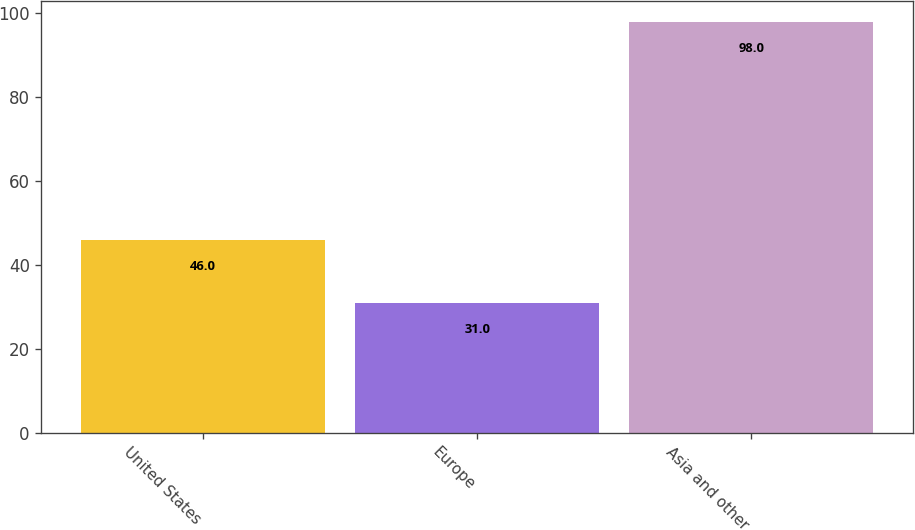Convert chart. <chart><loc_0><loc_0><loc_500><loc_500><bar_chart><fcel>United States<fcel>Europe<fcel>Asia and other<nl><fcel>46<fcel>31<fcel>98<nl></chart> 